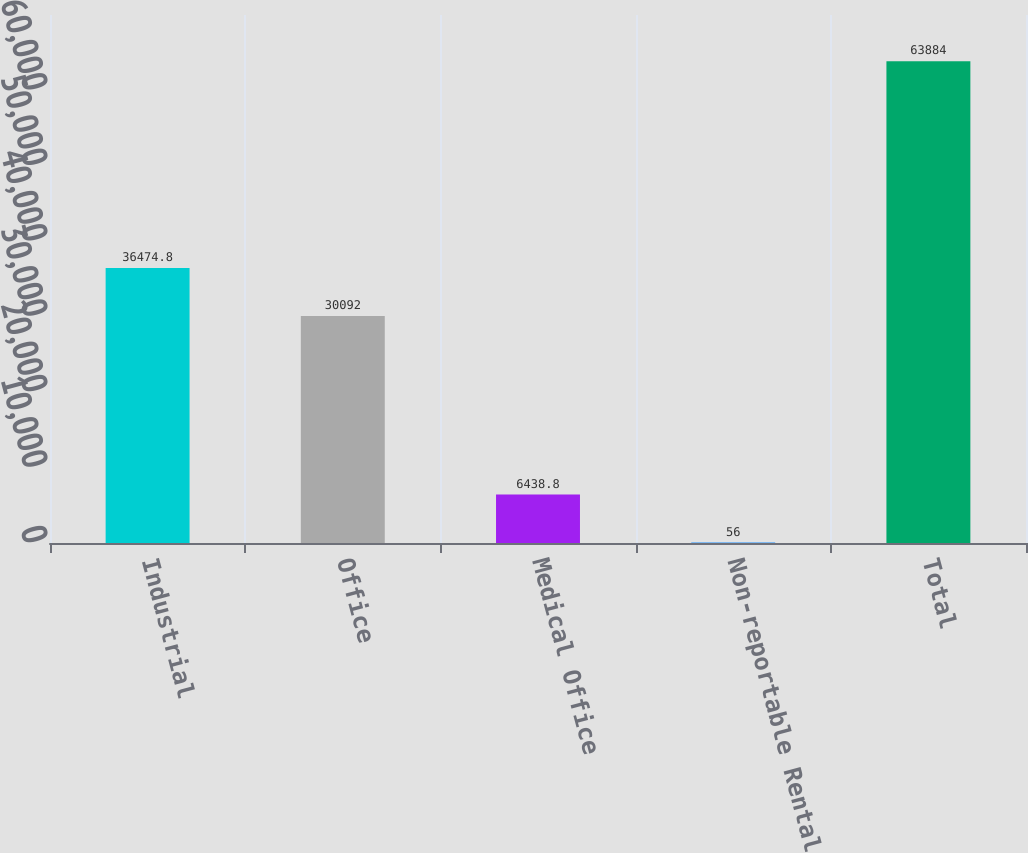<chart> <loc_0><loc_0><loc_500><loc_500><bar_chart><fcel>Industrial<fcel>Office<fcel>Medical Office<fcel>Non-reportable Rental<fcel>Total<nl><fcel>36474.8<fcel>30092<fcel>6438.8<fcel>56<fcel>63884<nl></chart> 